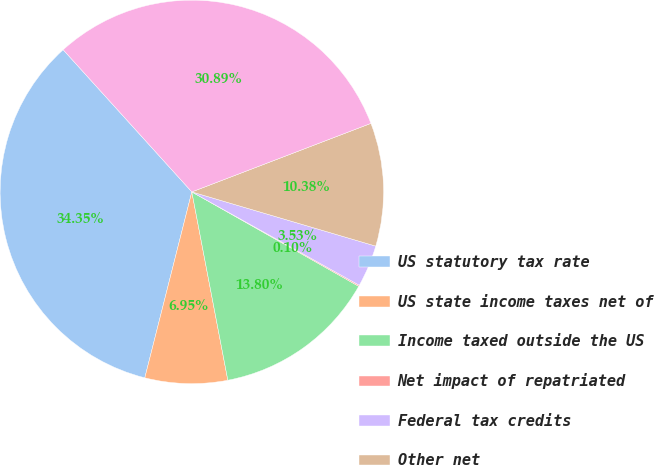<chart> <loc_0><loc_0><loc_500><loc_500><pie_chart><fcel>US statutory tax rate<fcel>US state income taxes net of<fcel>Income taxed outside the US<fcel>Net impact of repatriated<fcel>Federal tax credits<fcel>Other net<fcel>Effective income tax rate<nl><fcel>34.35%<fcel>6.95%<fcel>13.8%<fcel>0.1%<fcel>3.53%<fcel>10.38%<fcel>30.89%<nl></chart> 